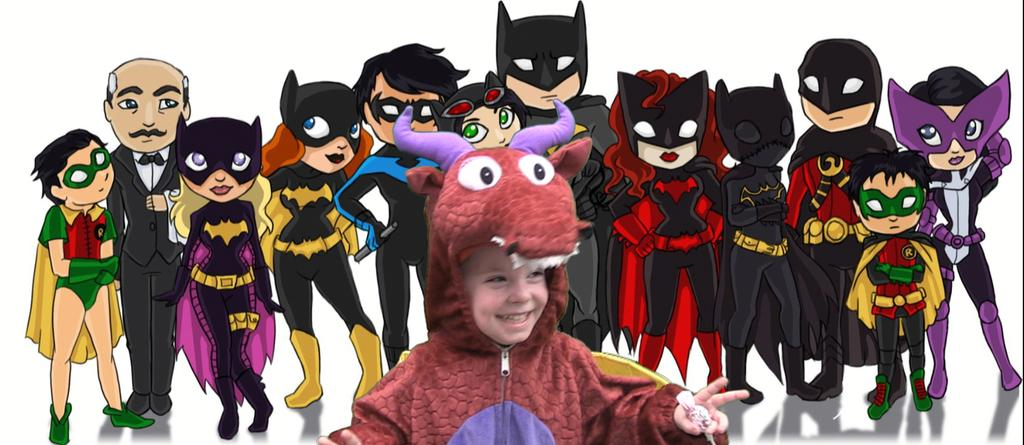Who is the main subject in the image? There is a boy in the image. What is the boy wearing? The boy is wearing a red costume dress. Where is the boy positioned in the image? The boy is standing in the front. What expression does the boy have? The boy is smiling. What can be seen in the background of the image? There is a cartoon poster in the background. What type of skate is the boy using in the image? There is no skate present in the image; the boy is wearing a red costume dress and standing in the front. 